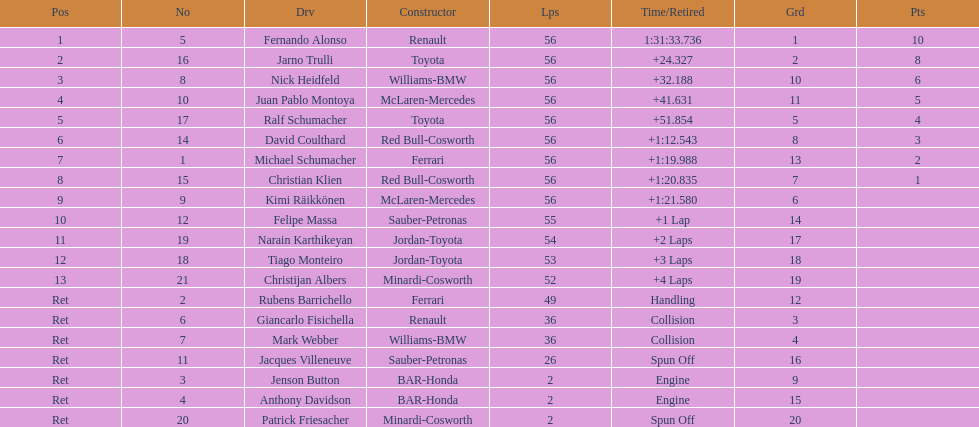How many germans finished in the top five? 2. 